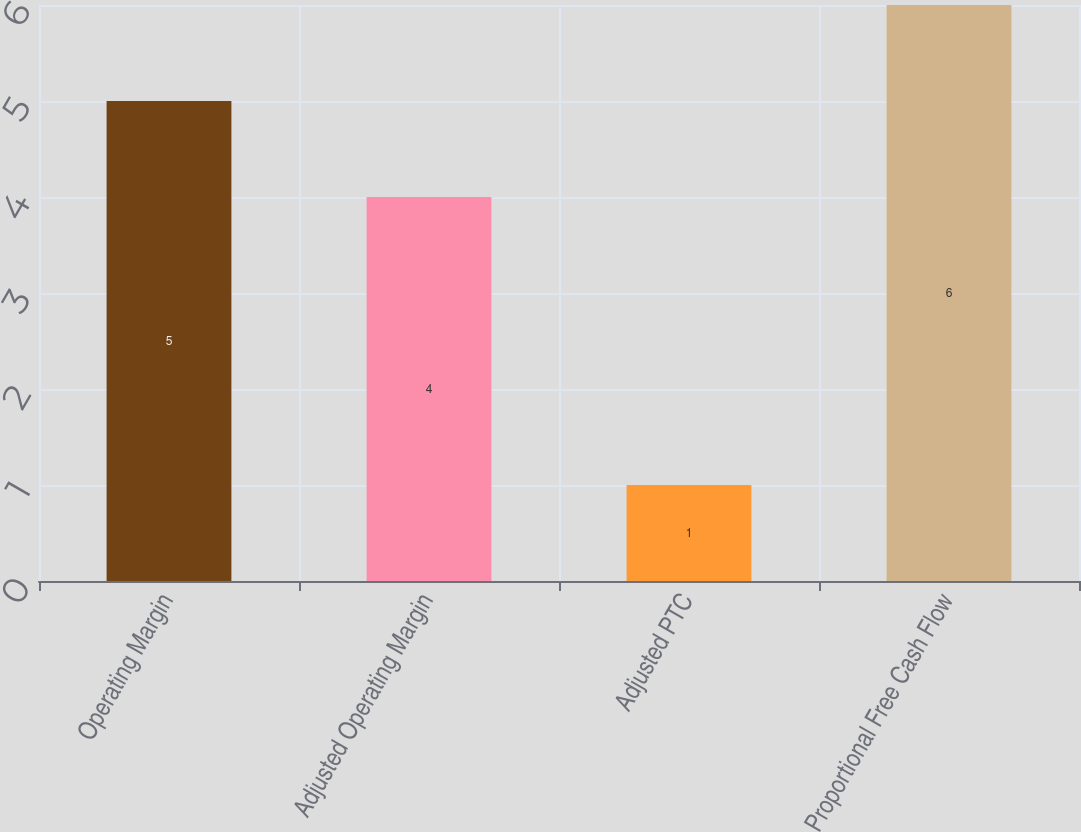Convert chart. <chart><loc_0><loc_0><loc_500><loc_500><bar_chart><fcel>Operating Margin<fcel>Adjusted Operating Margin<fcel>Adjusted PTC<fcel>Proportional Free Cash Flow<nl><fcel>5<fcel>4<fcel>1<fcel>6<nl></chart> 